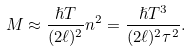<formula> <loc_0><loc_0><loc_500><loc_500>M \approx \frac { \hslash T } { ( 2 \ell ) ^ { 2 } } n ^ { 2 } = \frac { \hslash T ^ { 3 } } { ( 2 \ell ) ^ { 2 } \tau ^ { 2 } } .</formula> 